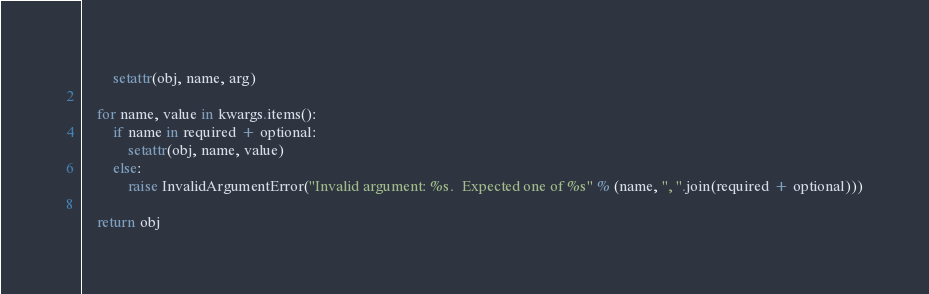Convert code to text. <code><loc_0><loc_0><loc_500><loc_500><_Python_>        setattr(obj, name, arg)

    for name, value in kwargs.items():
        if name in required + optional:
            setattr(obj, name, value)
        else:
            raise InvalidArgumentError("Invalid argument: %s.  Expected one of %s" % (name, ", ".join(required + optional)))

    return obj
</code> 